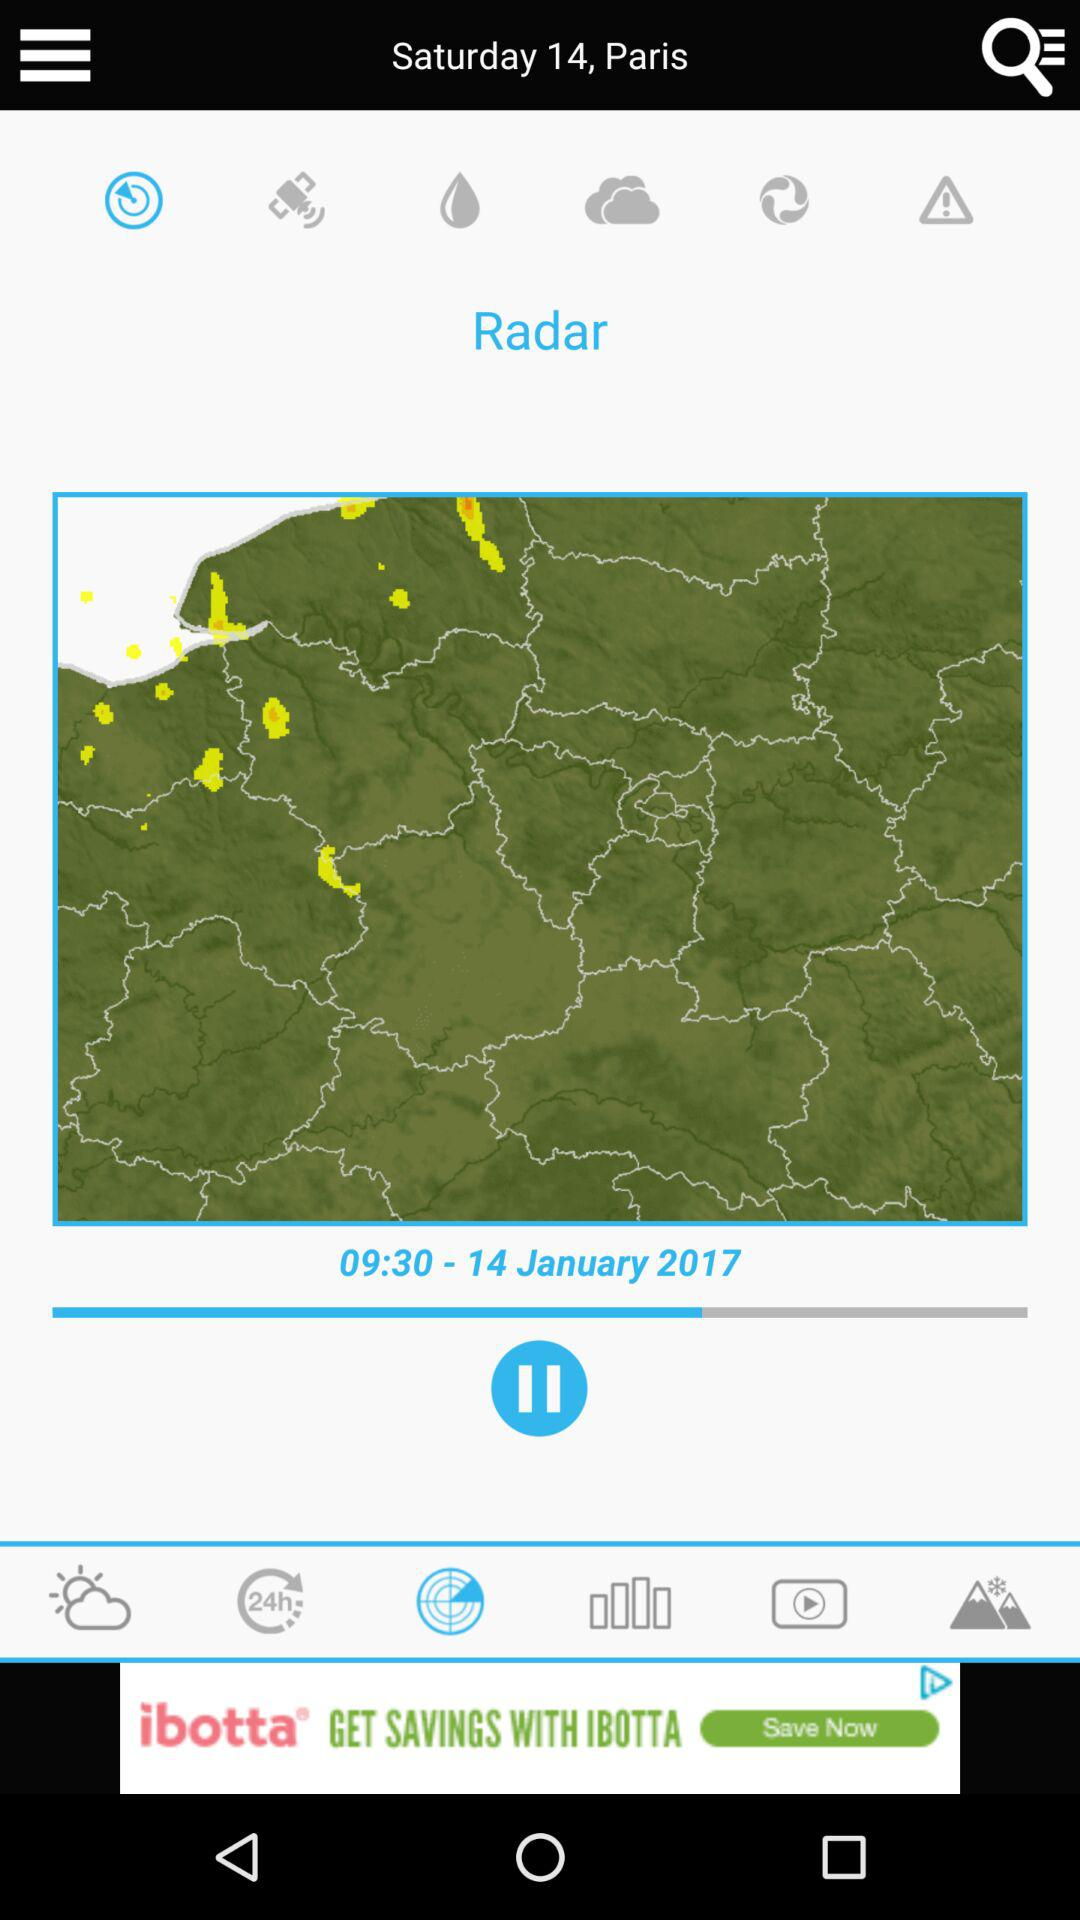What is the day on January 14? The day is Saturday. 